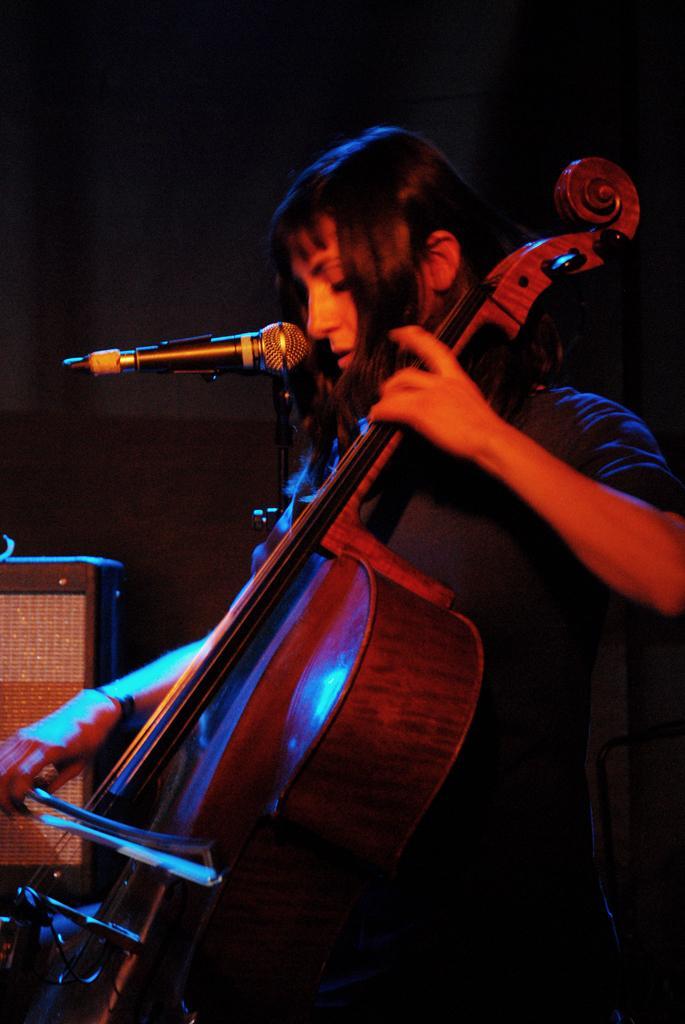In one or two sentences, can you explain what this image depicts? In this picture we can see a person is standing and playing Violin and singing a song with the microphone. 